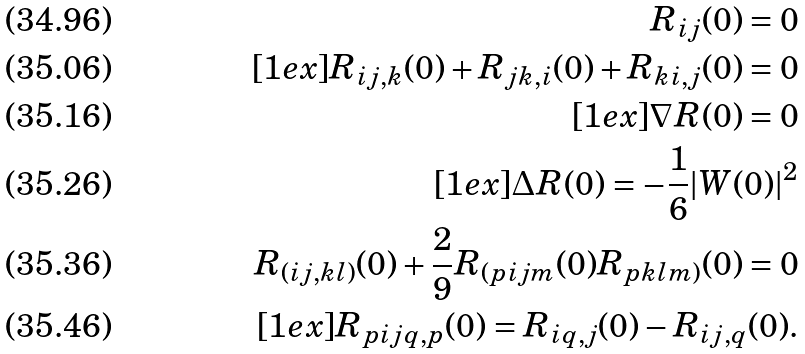<formula> <loc_0><loc_0><loc_500><loc_500>R _ { i j } ( 0 ) = 0 \\ [ 1 e x ] R _ { i j , k } ( 0 ) + R _ { j k , i } ( 0 ) + R _ { k i , j } ( 0 ) = 0 \\ [ 1 e x ] \nabla R ( 0 ) = 0 \\ [ 1 e x ] \Delta R ( 0 ) = - \frac { 1 } { 6 } | W ( 0 ) | ^ { 2 } \\ R _ { ( i j , k l ) } ( 0 ) + \frac { 2 } { 9 } R _ { ( p i j m } ( 0 ) R _ { p k l m ) } ( 0 ) = 0 \\ [ 1 e x ] R _ { p i j q , p } ( 0 ) = R _ { i q , j } ( 0 ) - R _ { i j , q } ( 0 ) .</formula> 